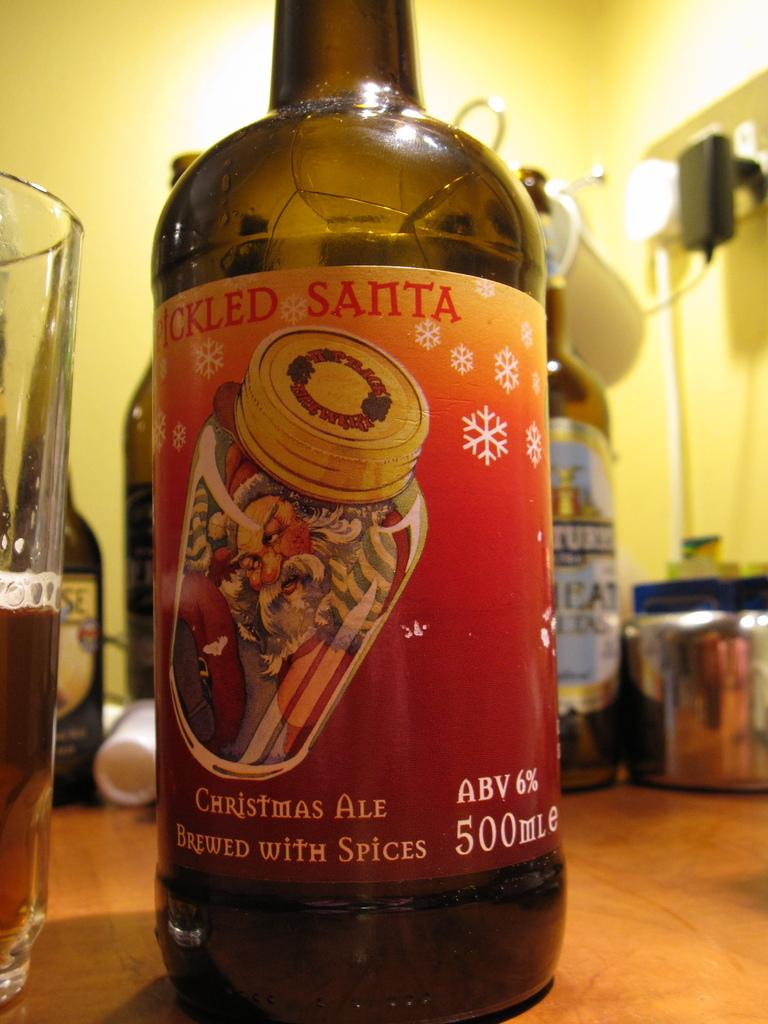<image>
Give a short and clear explanation of the subsequent image. A bottle of Christmas Ale sits on a table. 